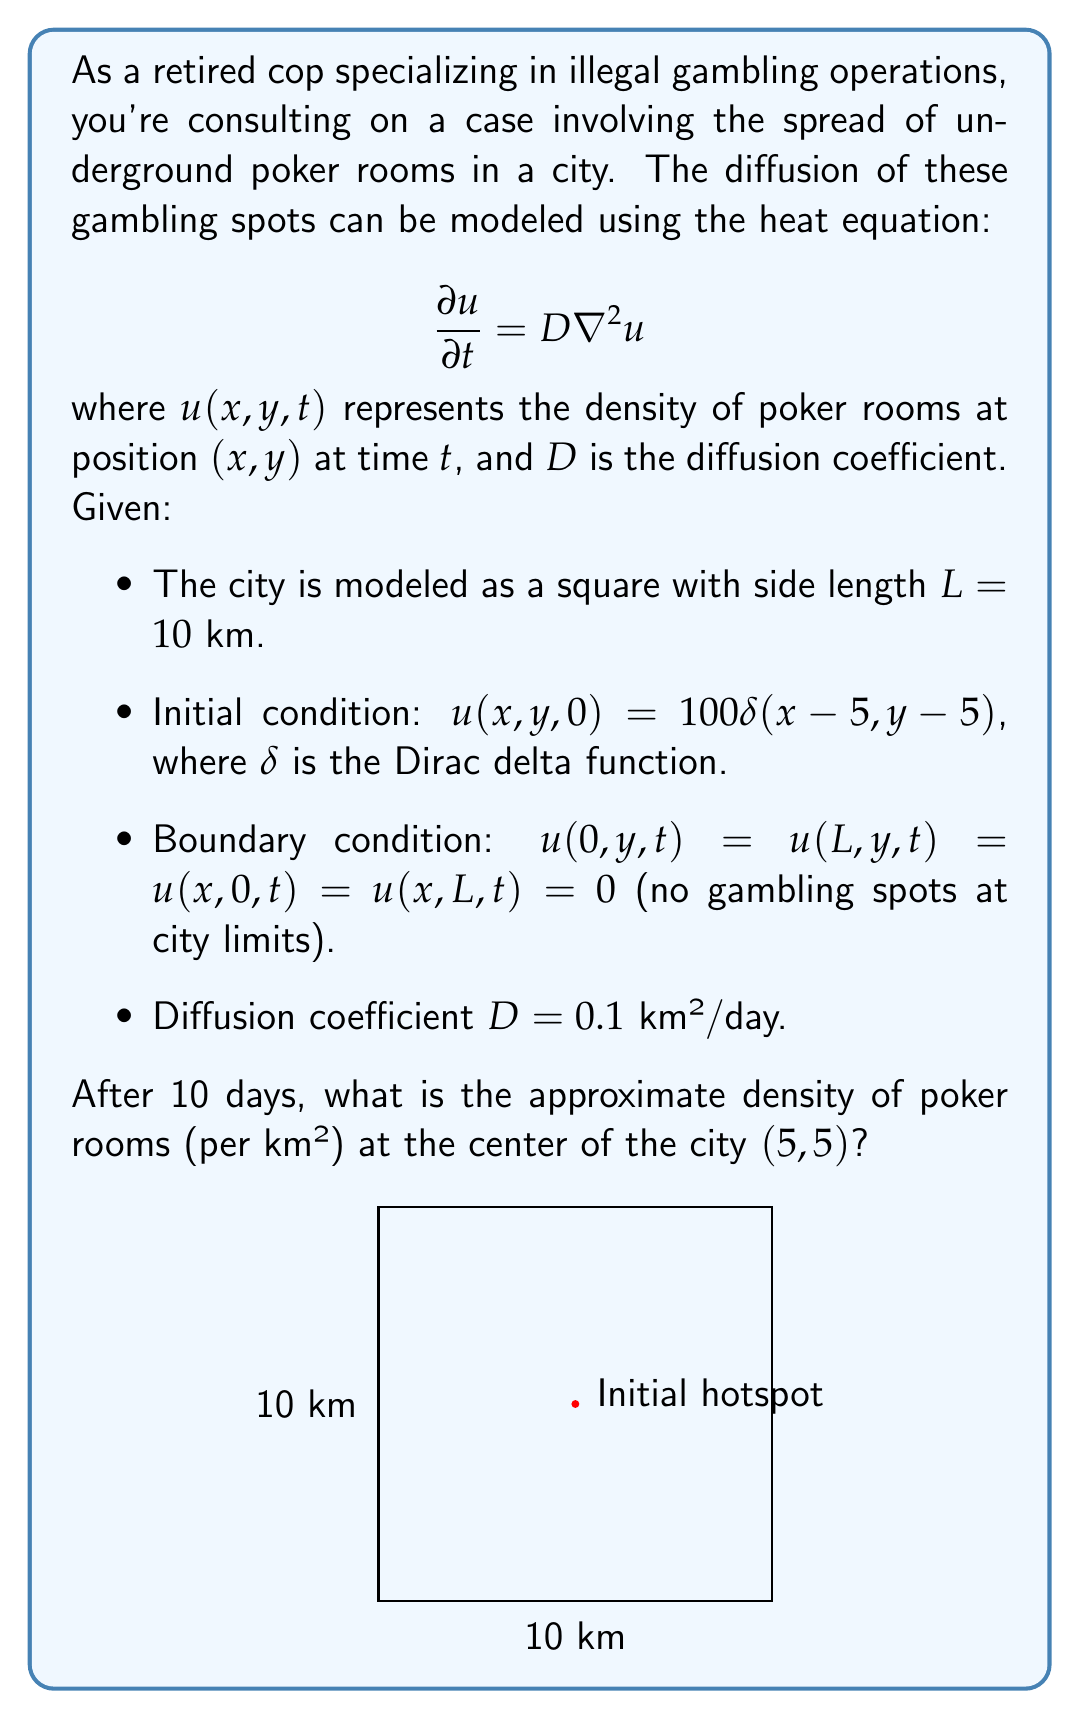Provide a solution to this math problem. To solve this problem, we'll use the solution to the 2D heat equation with a point source initial condition:

1) The solution for an infinite domain is:
   $$u(x,y,t) = \frac{M}{4\pi Dt} \exp\left(-\frac{(x-x_0)^2 + (y-y_0)^2}{4Dt}\right)$$
   where $M$ is the initial total number of poker rooms and $(x_0,y_0)$ is the initial location.

2) In our case, $M = 100$, $x_0 = y_0 = 5$, $D = 0.1$, and $t = 10$.

3) The boundary conditions will affect the solution, but for a first approximation, we can use the infinite domain solution.

4) Substituting the values:
   $$u(5,5,10) = \frac{100}{4\pi \cdot 0.1 \cdot 10} \exp\left(-\frac{(5-5)^2 + (5-5)^2}{4 \cdot 0.1 \cdot 10}\right)$$

5) Simplify:
   $$u(5,5,10) = \frac{100}{4\pi} \exp(0) = \frac{100}{4\pi} \approx 7.96$$

6) Therefore, the approximate density of poker rooms at the center of the city after 10 days is about 7.96 per km².

Note: This is an approximation as it doesn't account for the boundary conditions. In reality, the density would be slightly higher due to the reflection of the diffusion at the boundaries.
Answer: 7.96 poker rooms per km² 